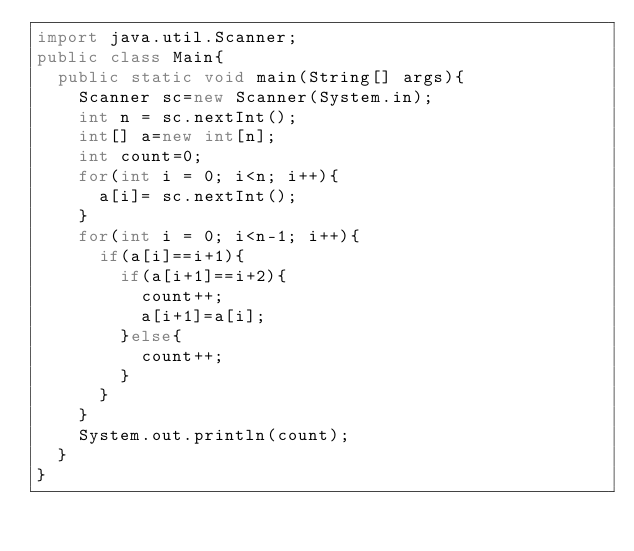<code> <loc_0><loc_0><loc_500><loc_500><_Java_>import java.util.Scanner;
public class Main{
	public static void main(String[] args){
		Scanner sc=new Scanner(System.in);
		int n = sc.nextInt();
		int[] a=new int[n];
		int count=0;
		for(int i = 0; i<n; i++){
			a[i]= sc.nextInt();
		}
		for(int i = 0; i<n-1; i++){
			if(a[i]==i+1){
				if(a[i+1]==i+2){
					count++;
					a[i+1]=a[i];
				}else{
					count++;
				}
			}
		}
		System.out.println(count);
	}
}</code> 